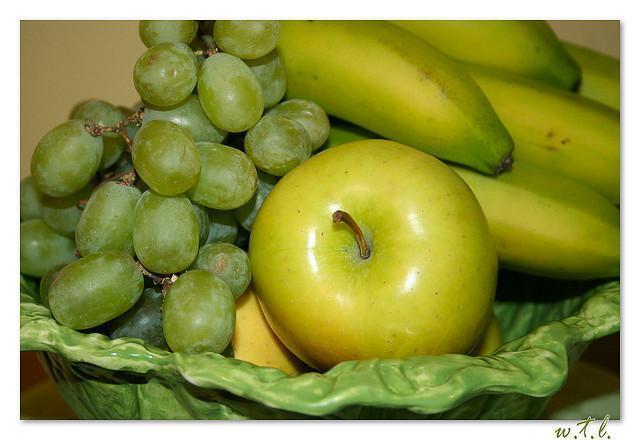How many bananas are in the picture?
Give a very brief answer. 5. How many skiiers are standing to the right of the train car?
Give a very brief answer. 0. 